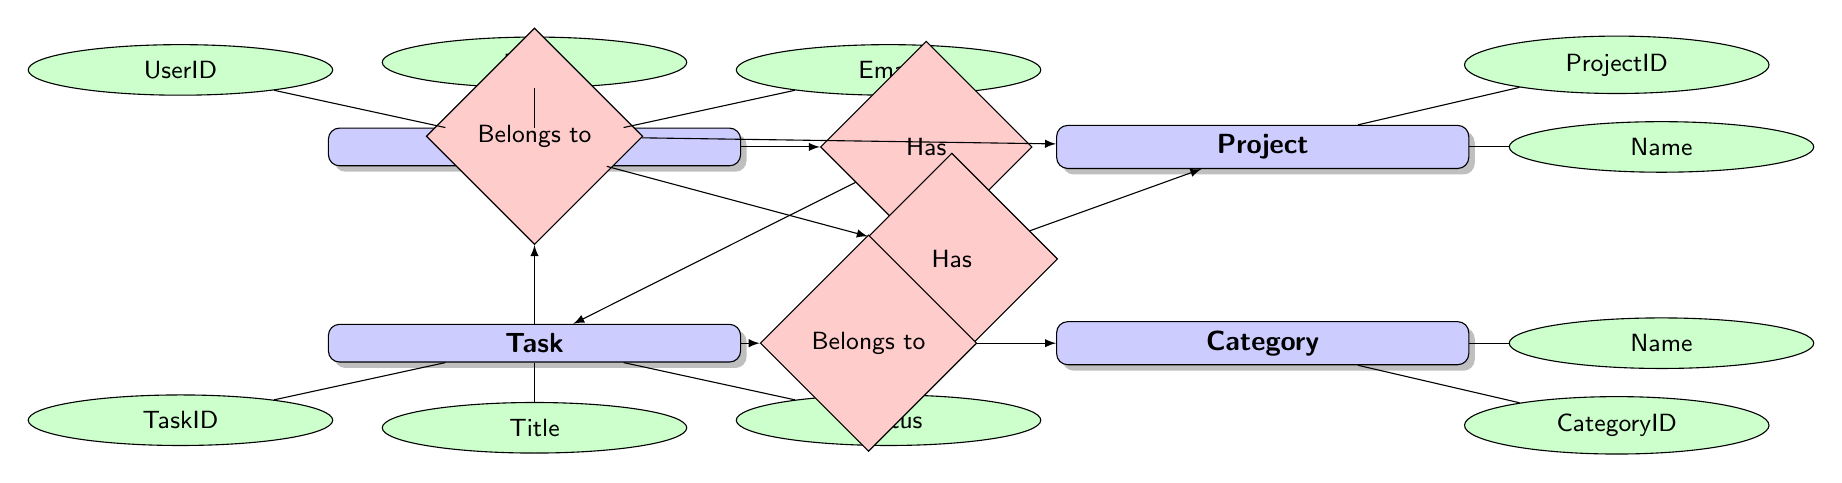What is the primary key for the User entity? The primary key for the User entity is represented by the attribute "UserID". This can be identified by looking at the attributes listed under the User entity in the diagram.
Answer: UserID How many relationships does the Task entity have? The Task entity has three relationships: it belongs to a User, belongs to a Project, and belongs to a Category. Each relationship is indicated clearly with arrows connecting the Task entity to the other entities.
Answer: 3 What type of relationship exists between User and Task? The relationship between User and Task is a "hasMany" relationship, indicating that a User can have multiple Tasks associated with them. This is shown in the diagram where the User points to the Task with a specific relationship type noted beside it.
Answer: hasMany Which attribute of the Project entity describes its timeline? The attribute that describes the timeline of the Project entity is "StartDate" and "EndDate". Both attributes manage the timeline aspect of a project, and they are clearly listed under the Project entity.
Answer: StartDate and EndDate What does the Category entity relate to? The Category entity relates to the Task entity with a "hasMany" relationship. This shows that multiple tasks can belong to a single category, and this relationship is visually represented by the arrow pointing from Task to Category with the specified relationship type.
Answer: Task What is the status of a Task? The status of a Task is indicated by the "Status" attribute in the Task entity. This attribute is part of the Task's set of characteristics and is connected directly to the Task node in the diagram.
Answer: Status Which two entities have a "belongsTo" relationship with Task? The Task entity has a "belongsTo" relationship with both User and Project entities. This is demonstrated in the diagram by arrows pointing from Task to both User and Project with the indicated relationship type.
Answer: User and Project How many attributes does the Category entity have? The Category entity has two attributes: "CategoryID" and "Name". These attributes are specified under the Category entity node in the diagram.
Answer: 2 